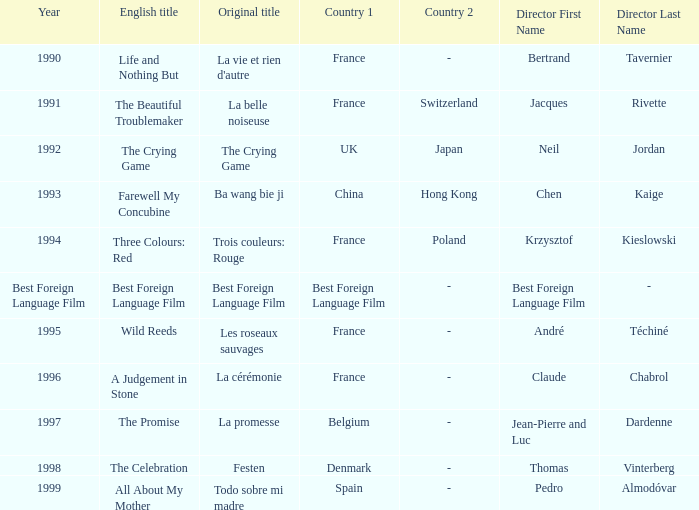What's the English title listed that has an Original title of The Crying Game? The Crying Game. 